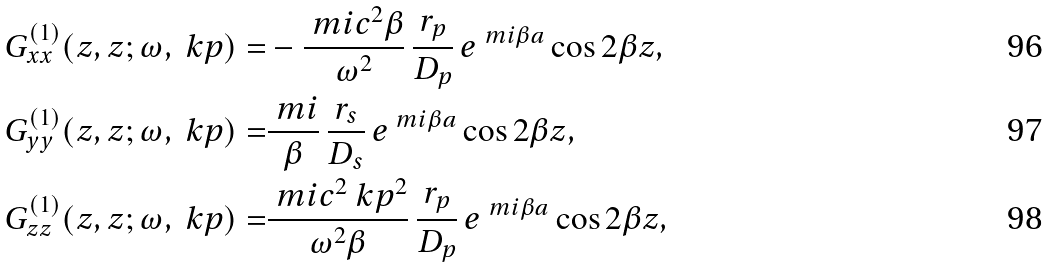Convert formula to latex. <formula><loc_0><loc_0><loc_500><loc_500>G ^ { ( 1 ) } _ { x x } ( z , z ; \omega , \ k p ) = & - \frac { \ m i c ^ { 2 } \beta } { \omega ^ { 2 } } \, \frac { r _ { p } } { D _ { p } } \, e ^ { \ m i \beta a } \cos 2 \beta z , \\ G ^ { ( 1 ) } _ { y y } ( z , z ; \omega , \ k p ) = & \frac { \ m i } { \beta } \, \frac { r _ { s } } { D _ { s } } \, e ^ { \ m i \beta a } \cos 2 \beta z , \\ G ^ { ( 1 ) } _ { z z } ( z , z ; \omega , \ k p ) = & \frac { \ m i c ^ { 2 } \ k p ^ { 2 } } { \omega ^ { 2 } \beta } \, \frac { r _ { p } } { D _ { p } } \, e ^ { \ m i \beta a } \cos 2 \beta z ,</formula> 